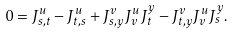Convert formula to latex. <formula><loc_0><loc_0><loc_500><loc_500>0 = J _ { s , t } ^ { u } - J _ { t , s } ^ { u } + J _ { s , y } ^ { v } J _ { v } ^ { u } J ^ { y } _ { t } - J _ { t , y } ^ { v } J _ { v } ^ { u } J _ { s } ^ { y } .</formula> 